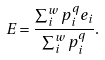Convert formula to latex. <formula><loc_0><loc_0><loc_500><loc_500>E = \frac { \sum _ { i } ^ { w } p _ { i } ^ { q } e _ { i } } { \sum _ { i } ^ { w } p _ { i } ^ { q } } .</formula> 